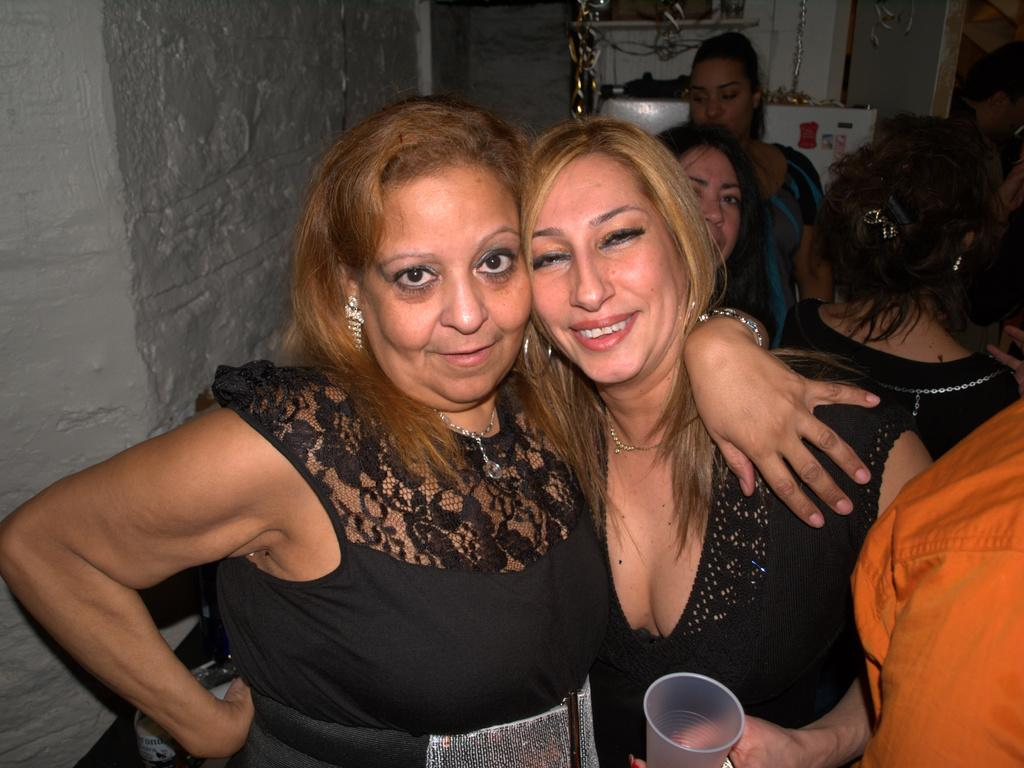What are the people in the image doing? The people in the image are standing. What is the woman holding in the image? The woman is holding a glass. What can be seen in the background of the image? There is a wall in the background of the image. What type of oil is being used by the people in the image? There is no mention of oil in the image. 